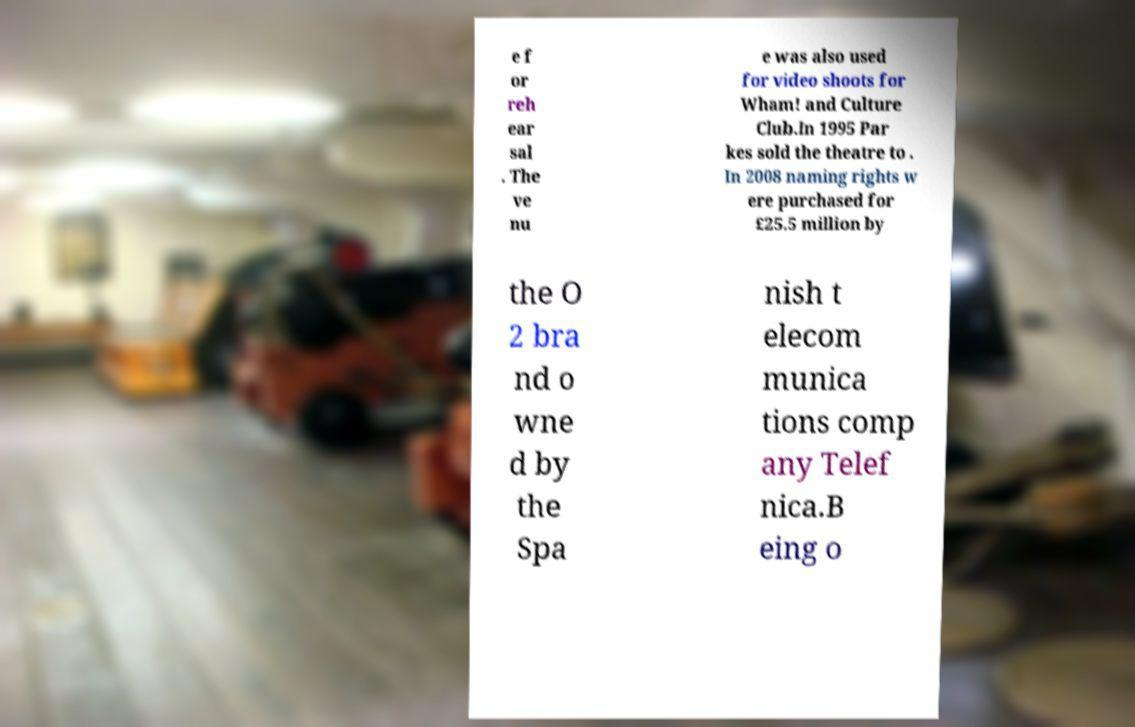Please read and relay the text visible in this image. What does it say? e f or reh ear sal . The ve nu e was also used for video shoots for Wham! and Culture Club.In 1995 Par kes sold the theatre to . In 2008 naming rights w ere purchased for £25.5 million by the O 2 bra nd o wne d by the Spa nish t elecom munica tions comp any Telef nica.B eing o 